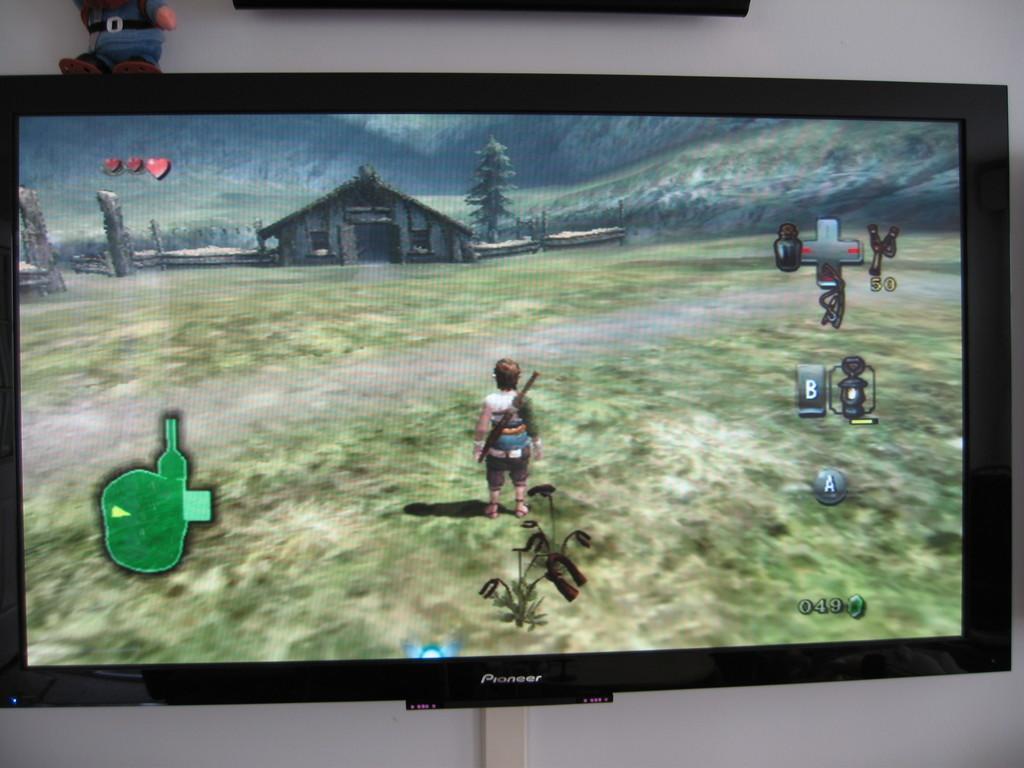Describe this image in one or two sentences. In this picture I can observe television in the middle of the picture. In the television screen I can observe video game. 